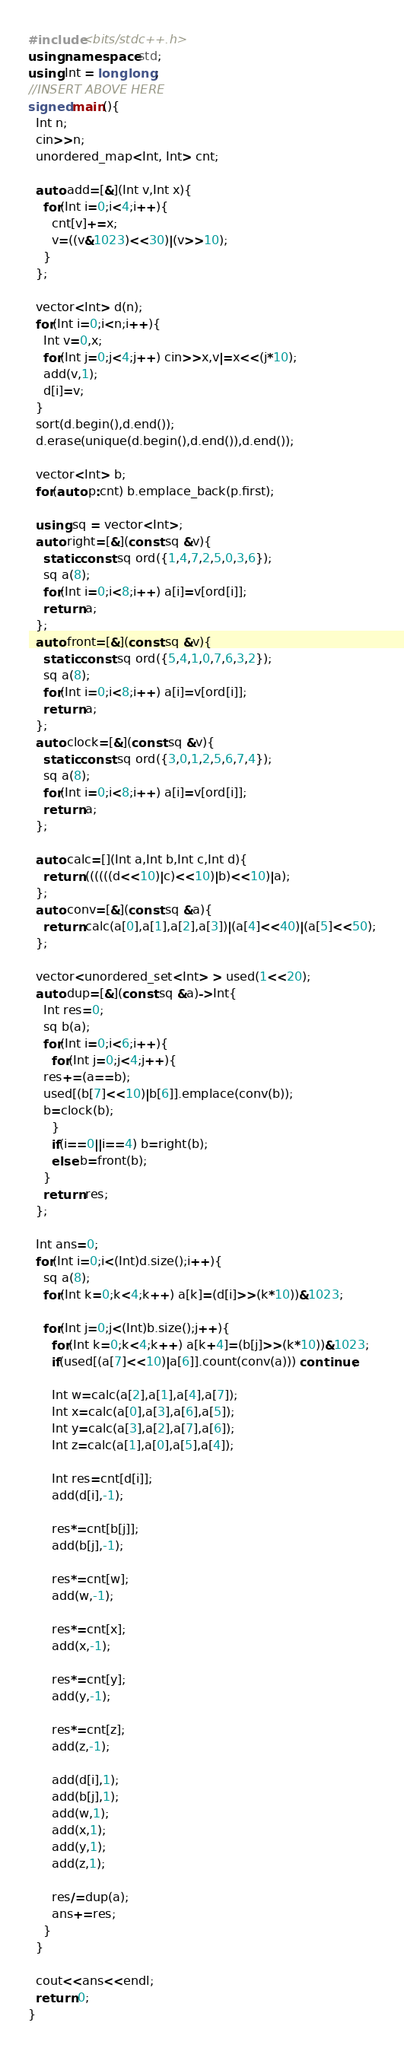Convert code to text. <code><loc_0><loc_0><loc_500><loc_500><_C++_>#include<bits/stdc++.h>
using namespace std;
using Int = long long;
//INSERT ABOVE HERE
signed main(){
  Int n;
  cin>>n;
  unordered_map<Int, Int> cnt;
  
  auto add=[&](Int v,Int x){
    for(Int i=0;i<4;i++){
      cnt[v]+=x;
      v=((v&1023)<<30)|(v>>10);
    }
  };

  vector<Int> d(n);
  for(Int i=0;i<n;i++){
    Int v=0,x;
    for(Int j=0;j<4;j++) cin>>x,v|=x<<(j*10);
    add(v,1);
    d[i]=v;
  }
  sort(d.begin(),d.end());
  d.erase(unique(d.begin(),d.end()),d.end());
  
  vector<Int> b;
  for(auto p:cnt) b.emplace_back(p.first);

  using sq = vector<Int>;
  auto right=[&](const sq &v){
    static const sq ord({1,4,7,2,5,0,3,6});
    sq a(8);
    for(Int i=0;i<8;i++) a[i]=v[ord[i]];
    return a;
  };
  auto front=[&](const sq &v){
    static const sq ord({5,4,1,0,7,6,3,2});
    sq a(8);
    for(Int i=0;i<8;i++) a[i]=v[ord[i]];
    return a;
  };  
  auto clock=[&](const sq &v){
    static const sq ord({3,0,1,2,5,6,7,4});
    sq a(8);
    for(Int i=0;i<8;i++) a[i]=v[ord[i]];
    return a;
  };

  auto calc=[](Int a,Int b,Int c,Int d){
    return ((((((d<<10)|c)<<10)|b)<<10)|a);
  };
  auto conv=[&](const sq &a){
    return calc(a[0],a[1],a[2],a[3])|(a[4]<<40)|(a[5]<<50);
  };

  vector<unordered_set<Int> > used(1<<20);
  auto dup=[&](const sq &a)->Int{
    Int res=0;
    sq b(a);
    for(Int i=0;i<6;i++){
      for(Int j=0;j<4;j++){
	res+=(a==b);
	used[(b[7]<<10)|b[6]].emplace(conv(b));
	b=clock(b);
      }
      if(i==0||i==4) b=right(b);
      else b=front(b);
    }
    return res;
  };

  Int ans=0;
  for(Int i=0;i<(Int)d.size();i++){
    sq a(8);
    for(Int k=0;k<4;k++) a[k]=(d[i]>>(k*10))&1023;
    
    for(Int j=0;j<(Int)b.size();j++){
      for(Int k=0;k<4;k++) a[k+4]=(b[j]>>(k*10))&1023;
      if(used[(a[7]<<10)|a[6]].count(conv(a))) continue;
      
      Int w=calc(a[2],a[1],a[4],a[7]);
      Int x=calc(a[0],a[3],a[6],a[5]);
      Int y=calc(a[3],a[2],a[7],a[6]);
      Int z=calc(a[1],a[0],a[5],a[4]);
      
      Int res=cnt[d[i]];
      add(d[i],-1);      
      
      res*=cnt[b[j]];      
      add(b[j],-1);            
      
      res*=cnt[w];
      add(w,-1);

      res*=cnt[x];
      add(x,-1);

      res*=cnt[y];
      add(y,-1);

      res*=cnt[z];
      add(z,-1);

      add(d[i],1);
      add(b[j],1);
      add(w,1);
      add(x,1);
      add(y,1);
      add(z,1);
      
      res/=dup(a);
      ans+=res;
    }
  }

  cout<<ans<<endl;
  return 0;
}
</code> 